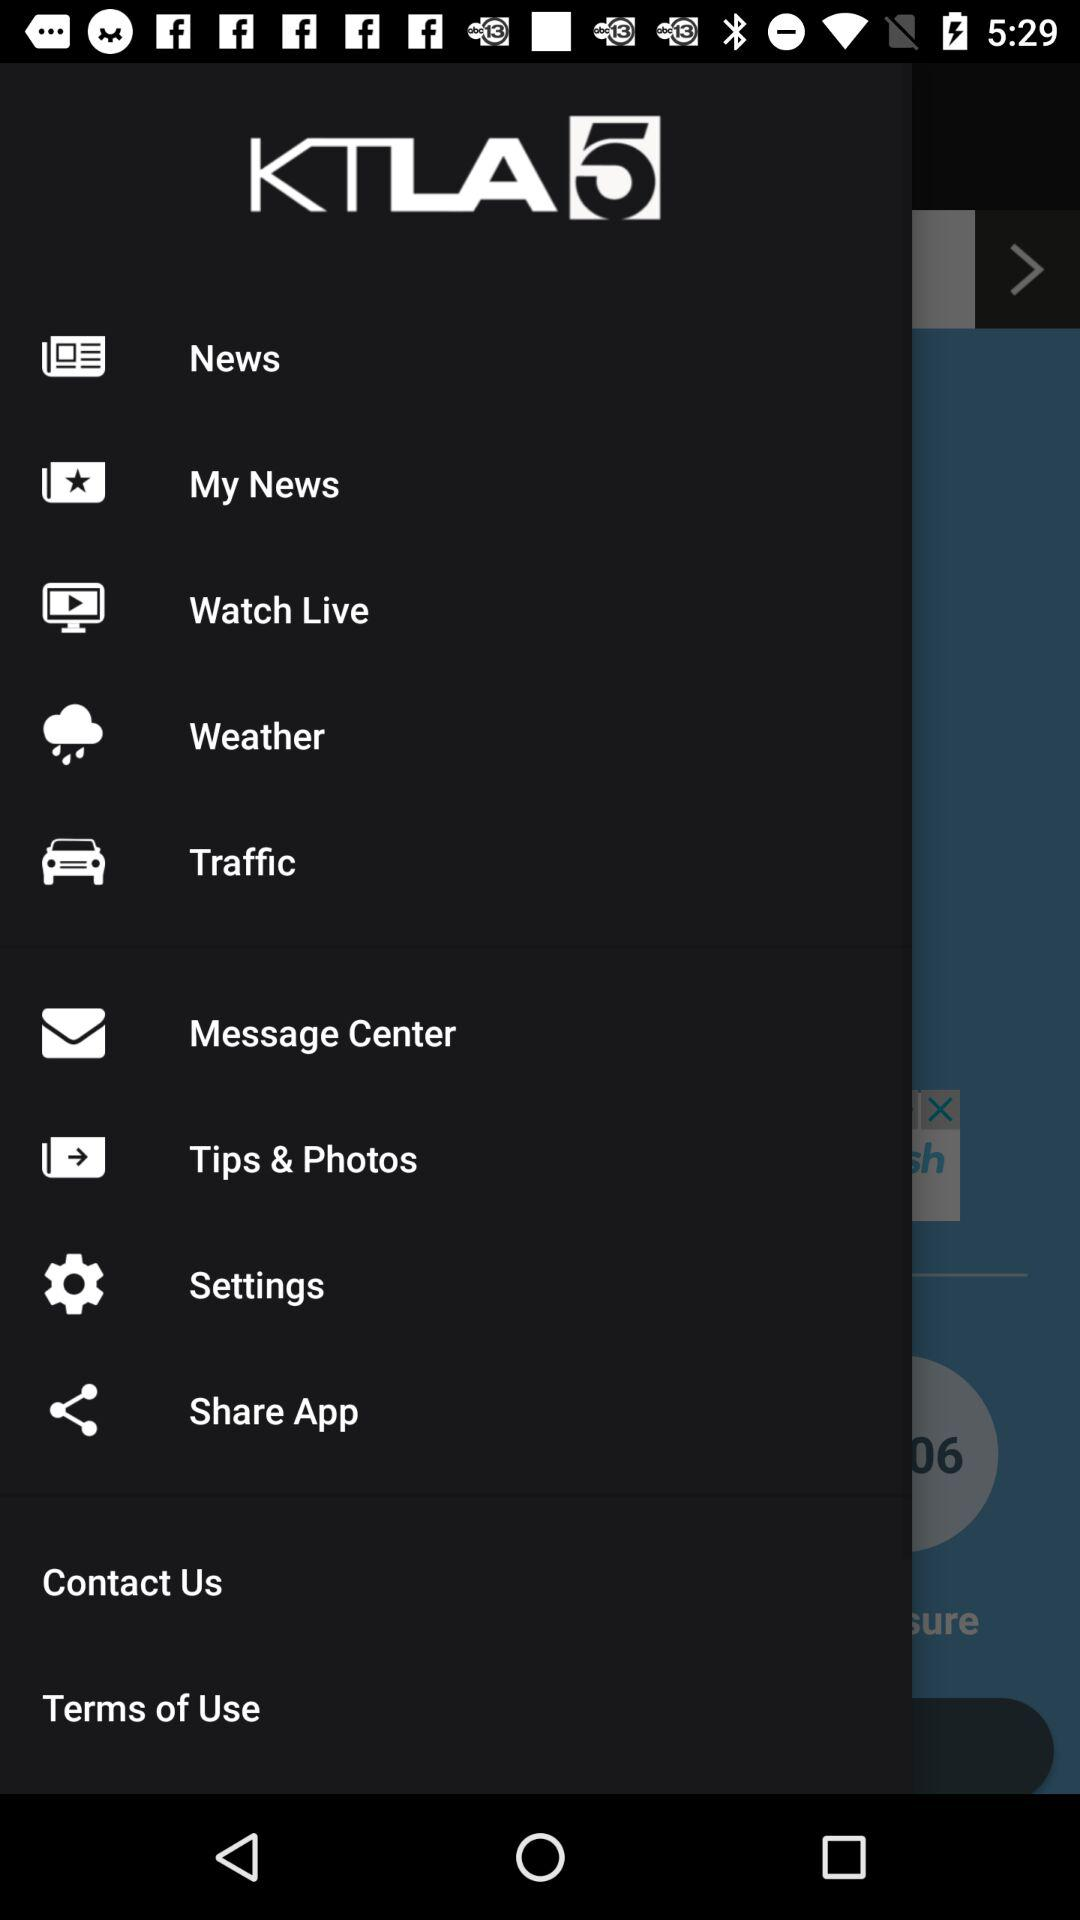What is the application name? The application name is "KTLA 5". 